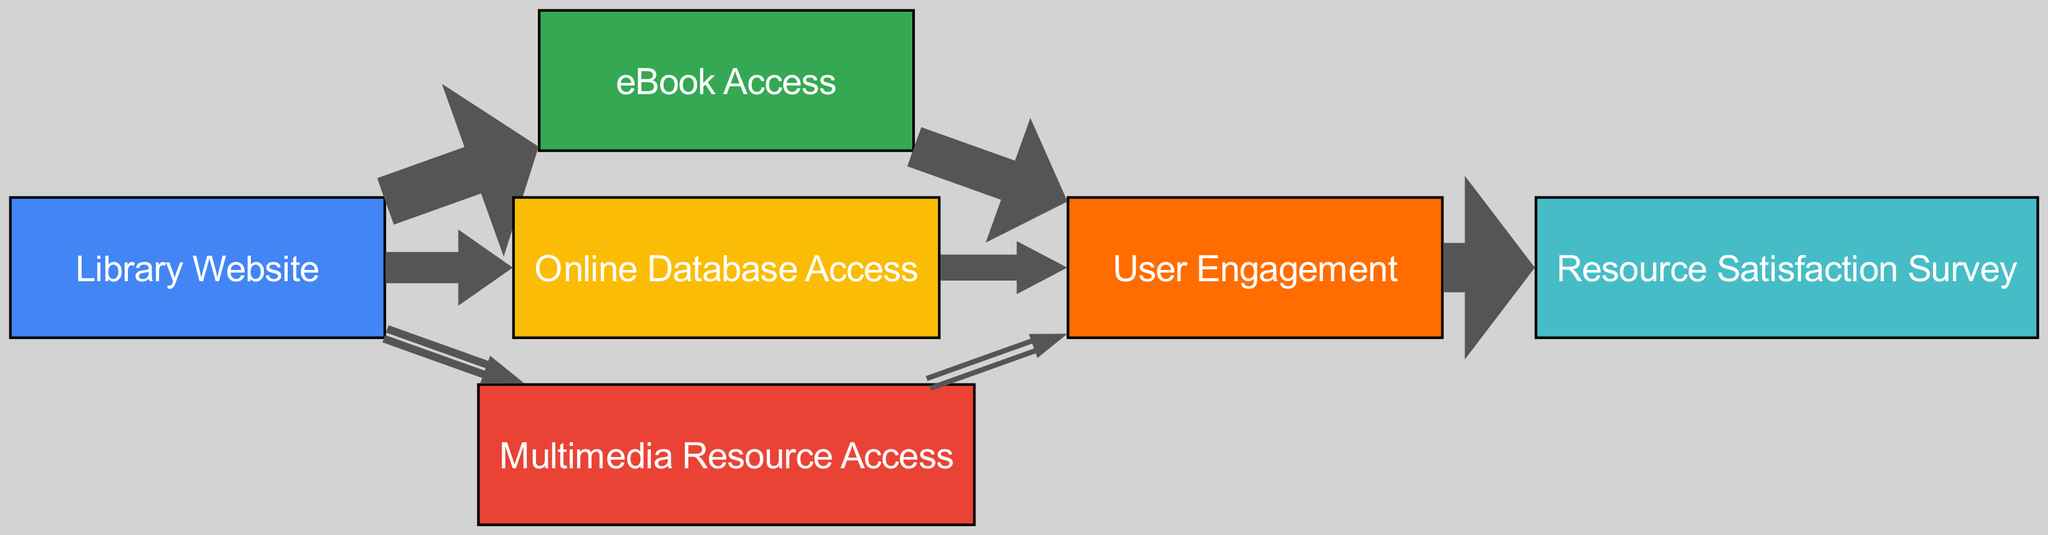what is the total number of resources accessed from the library website? To find the total number of resources accessed from the library website, we need to sum the values of the outgoing links from the "Library Website" node. The values are 1500 for eBook Access, 800 for Online Database Access, and 300 for Multimedia Resource Access. Adding these together: 1500 + 800 + 300 = 2600.
Answer: 2600 which resource has the highest user engagement? To determine which resource has the highest user engagement, we look at the values of the outgoing links from each resource to the "User Engagement" node: eBook Access has 1200, Online Database Access has 600, and Multimedia Resource Access has 200. The highest value is 1200 from eBook Access.
Answer: eBook Access how many nodes are present in total in the diagram? The total number of nodes can be found by counting the distinct nodes listed. There are six nodes: Library Website, eBook Access, Online Database Access, Multimedia Resource Access, User Engagement, and Resource Satisfaction Survey. This totals to six nodes.
Answer: 6 what percentage of users engaged with eBooks compared to the total user engagement? First, we need to find the total user engagement, which is the sum of all outgoing links from the "User Engagement" node, which totals 1500. The engagement for eBooks is 1200, so we calculate the percentage as (1200 / 1500) * 100 = 80%.
Answer: 80% what is the flow value from online database access to user engagement? We can see that the link from the "Online Database Access" node to "User Engagement" has a flow value of 600, which is directly shown in the diagram.
Answer: 600 which node has the least user engagement? To identify the node with the least user engagement, we compare the values of the outgoing links to the "User Engagement" node: 1200 from eBook Access, 600 from Online Database Access, and 200 from Multimedia Resource Access. The lowest value is 200 from Multimedia Resource Access.
Answer: Multimedia Resource Access which resource had a direct connection to resource satisfaction survey? The only node that has a direct connection to the "Resource Satisfaction Survey" is "User Engagement." There are no other nodes directly connected to it in the diagram.
Answer: User Engagement how many resources had access numbers above 500? The resources with access numbers above 500 are eBook Access (1500) and Online Database Access (800). Therefore, we have two resources exceeding that threshold.
Answer: 2 what is the total user engagement value? The total user engagement value can be calculated by adding the individual engagements: 1200 from eBook Access, 600 from Online Database Access, and 200 from Multimedia Resource Access, totaling 1200 + 600 + 200 = 2000.
Answer: 2000 